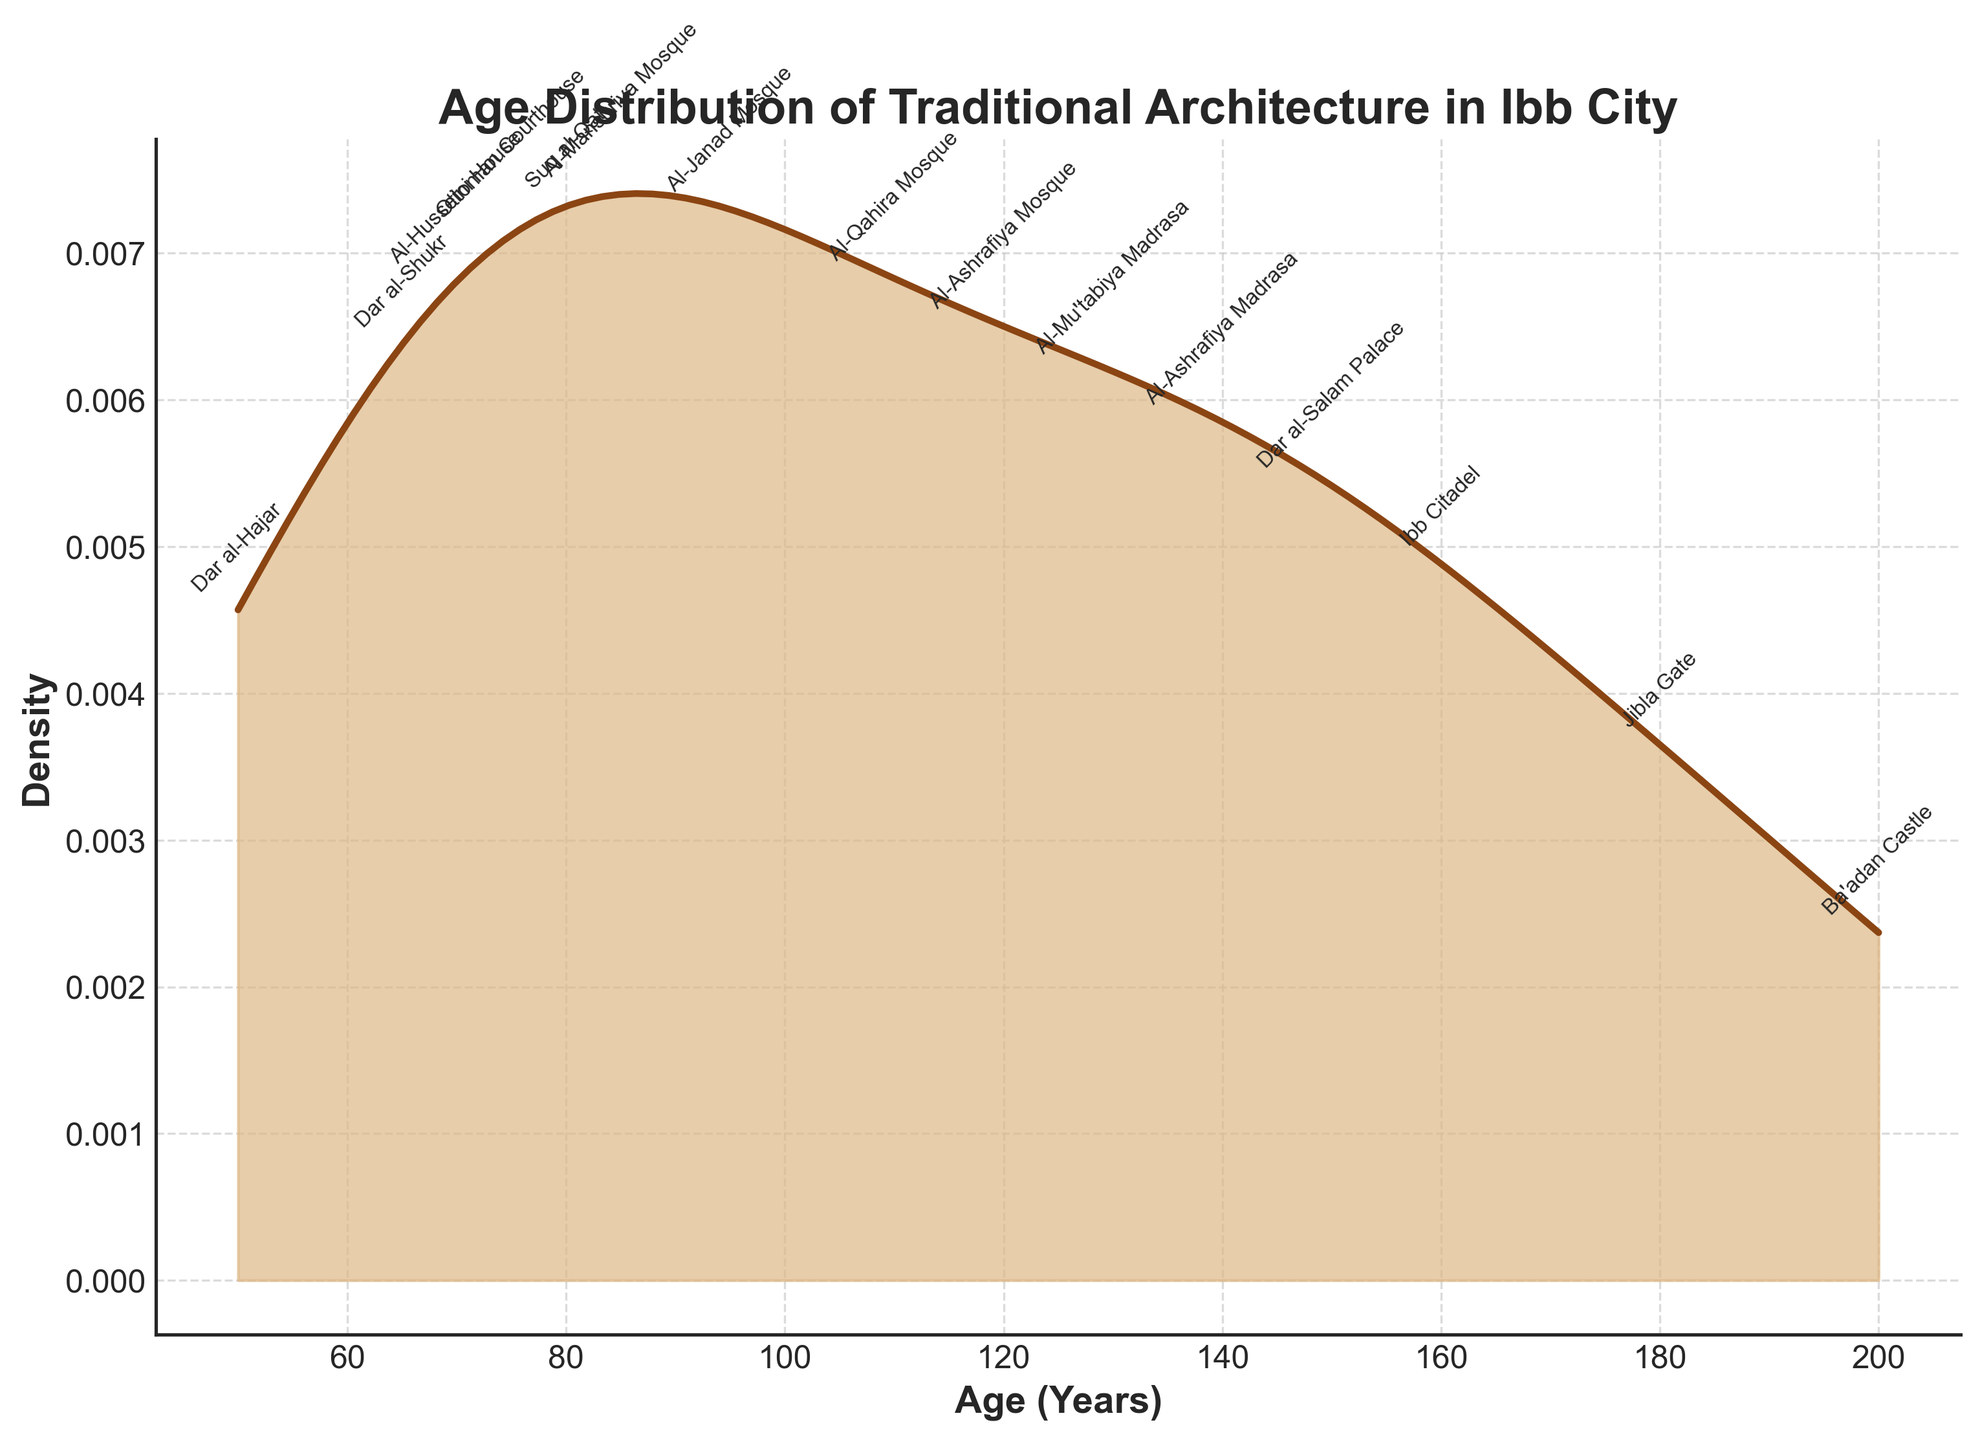What's the title of the figure? The title is typically at the top of the figure in bold, summarizing the content.
Answer: Age Distribution of Traditional Architecture in Ibb City What is the x-axis label? The x-axis label is a descriptive text near the horizontal axis, explaining what the axis represents.
Answer: Age (Years) What colors are used in the plot? The colors used are often visible in the plot's lines or fills and are described naturally.
Answer: Brown and light brown How many buildings from the Late Ottoman Period are shown in the plot? The data annotations on the plot will indicate the number of buildings belonging to each period. By counting, we find three buildings: Suq al-Qat, Dar al-Shukr, and Ottoman Courthouse.
Answer: Three What's the range of ages for the buildings? The x-axis shows the range of ages. The minimum is 50 years and the maximum is 200 years.
Answer: 50 to 200 years Which building has the highest age density? The peak of the density curve corresponds to the building age with the highest density. By looking at the tallest peak on the plot and its x-axis value, we find the buildings around that age.
Answer: Al-Janad Mosque Are the majority of the buildings older or younger than 100 years? The density plot's shape will indicate the distribution concentration. By analyzing the width and concentration, we notice more density on the older-than-100-years side.
Answer: Older Which era has the oldest building? By identifying the building with the maximum age and checking its historical period. Ba'adan Castle has the age of 200 years from the Himyarite Kingdom.
Answer: Himyarite Kingdom What is the average age of the buildings? Sum the ages and divide by the number of buildings. (50+120+80+180+95+150+70+200+110+65+130+85+160+75+140)/15 = 119.667.
Answer: ~120 years How many buildings are from the Rasulid Dynasty? By checking the annotations, counts show three buildings: Al-Ashrafiya Mosque, Al-Mu'tabiya Madrasa, and Al-Ashrafiya Madrasa.
Answer: Three 